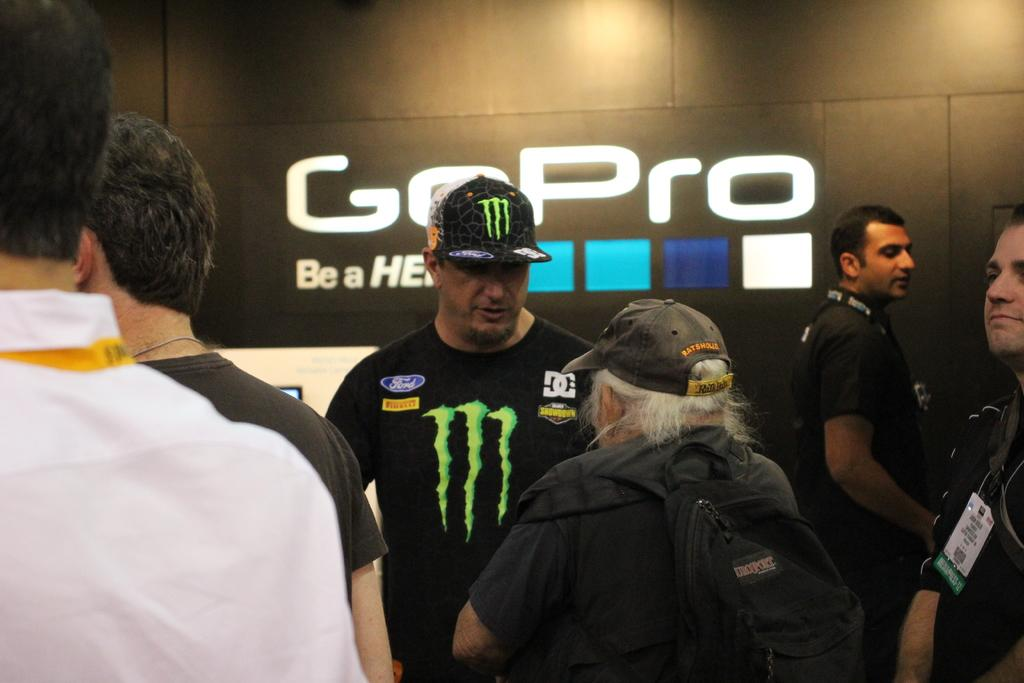<image>
Create a compact narrative representing the image presented. A man wearing a Monster shirt and hat stands in front of a GoPro sign 